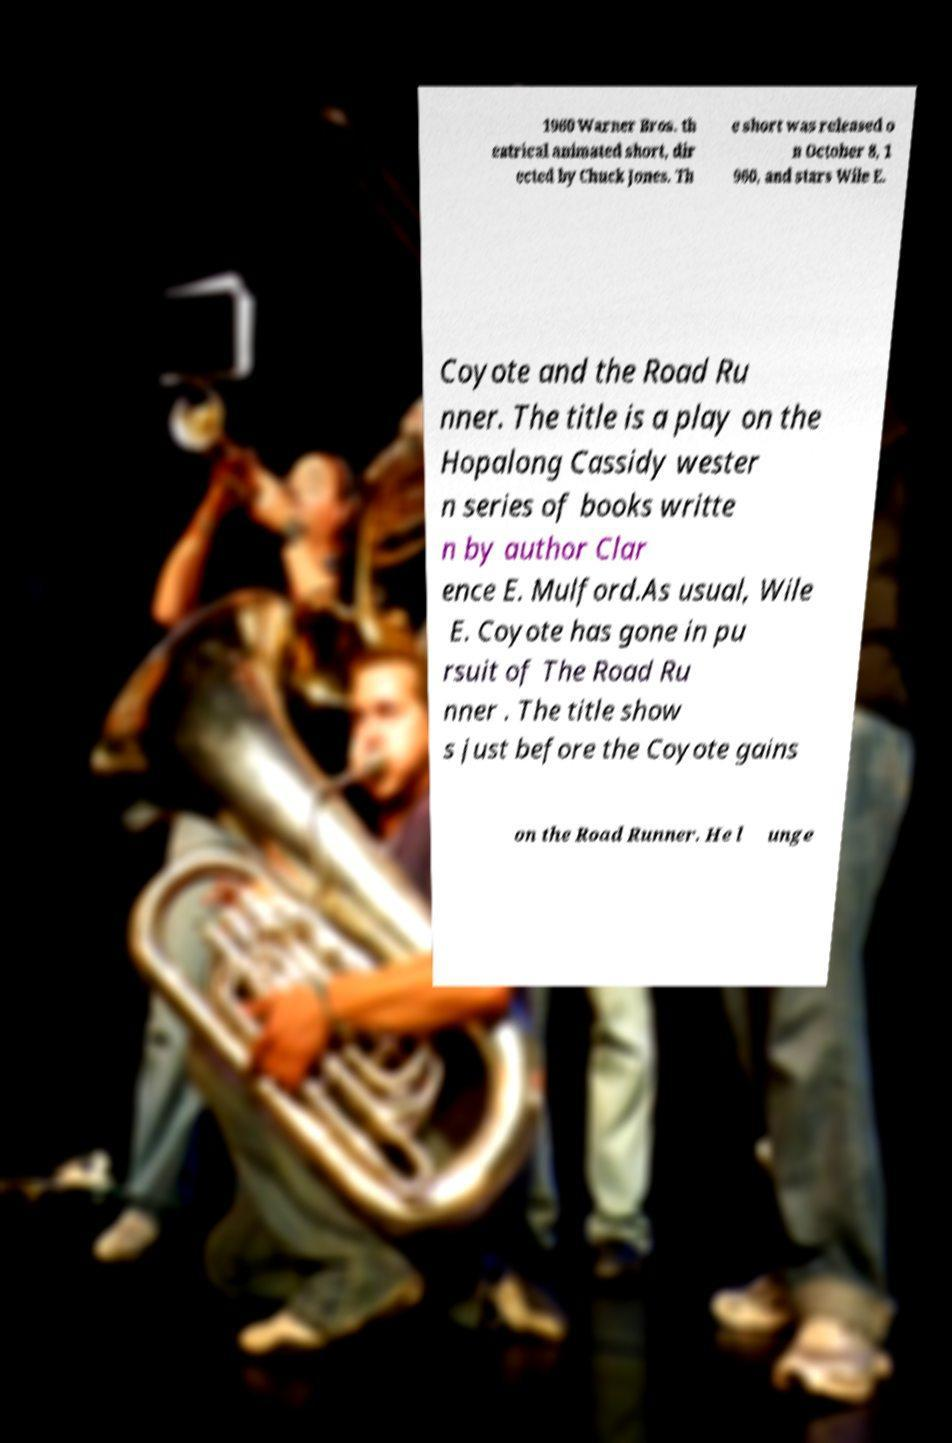What messages or text are displayed in this image? I need them in a readable, typed format. 1960 Warner Bros. th eatrical animated short, dir ected by Chuck Jones. Th e short was released o n October 8, 1 960, and stars Wile E. Coyote and the Road Ru nner. The title is a play on the Hopalong Cassidy wester n series of books writte n by author Clar ence E. Mulford.As usual, Wile E. Coyote has gone in pu rsuit of The Road Ru nner . The title show s just before the Coyote gains on the Road Runner. He l unge 